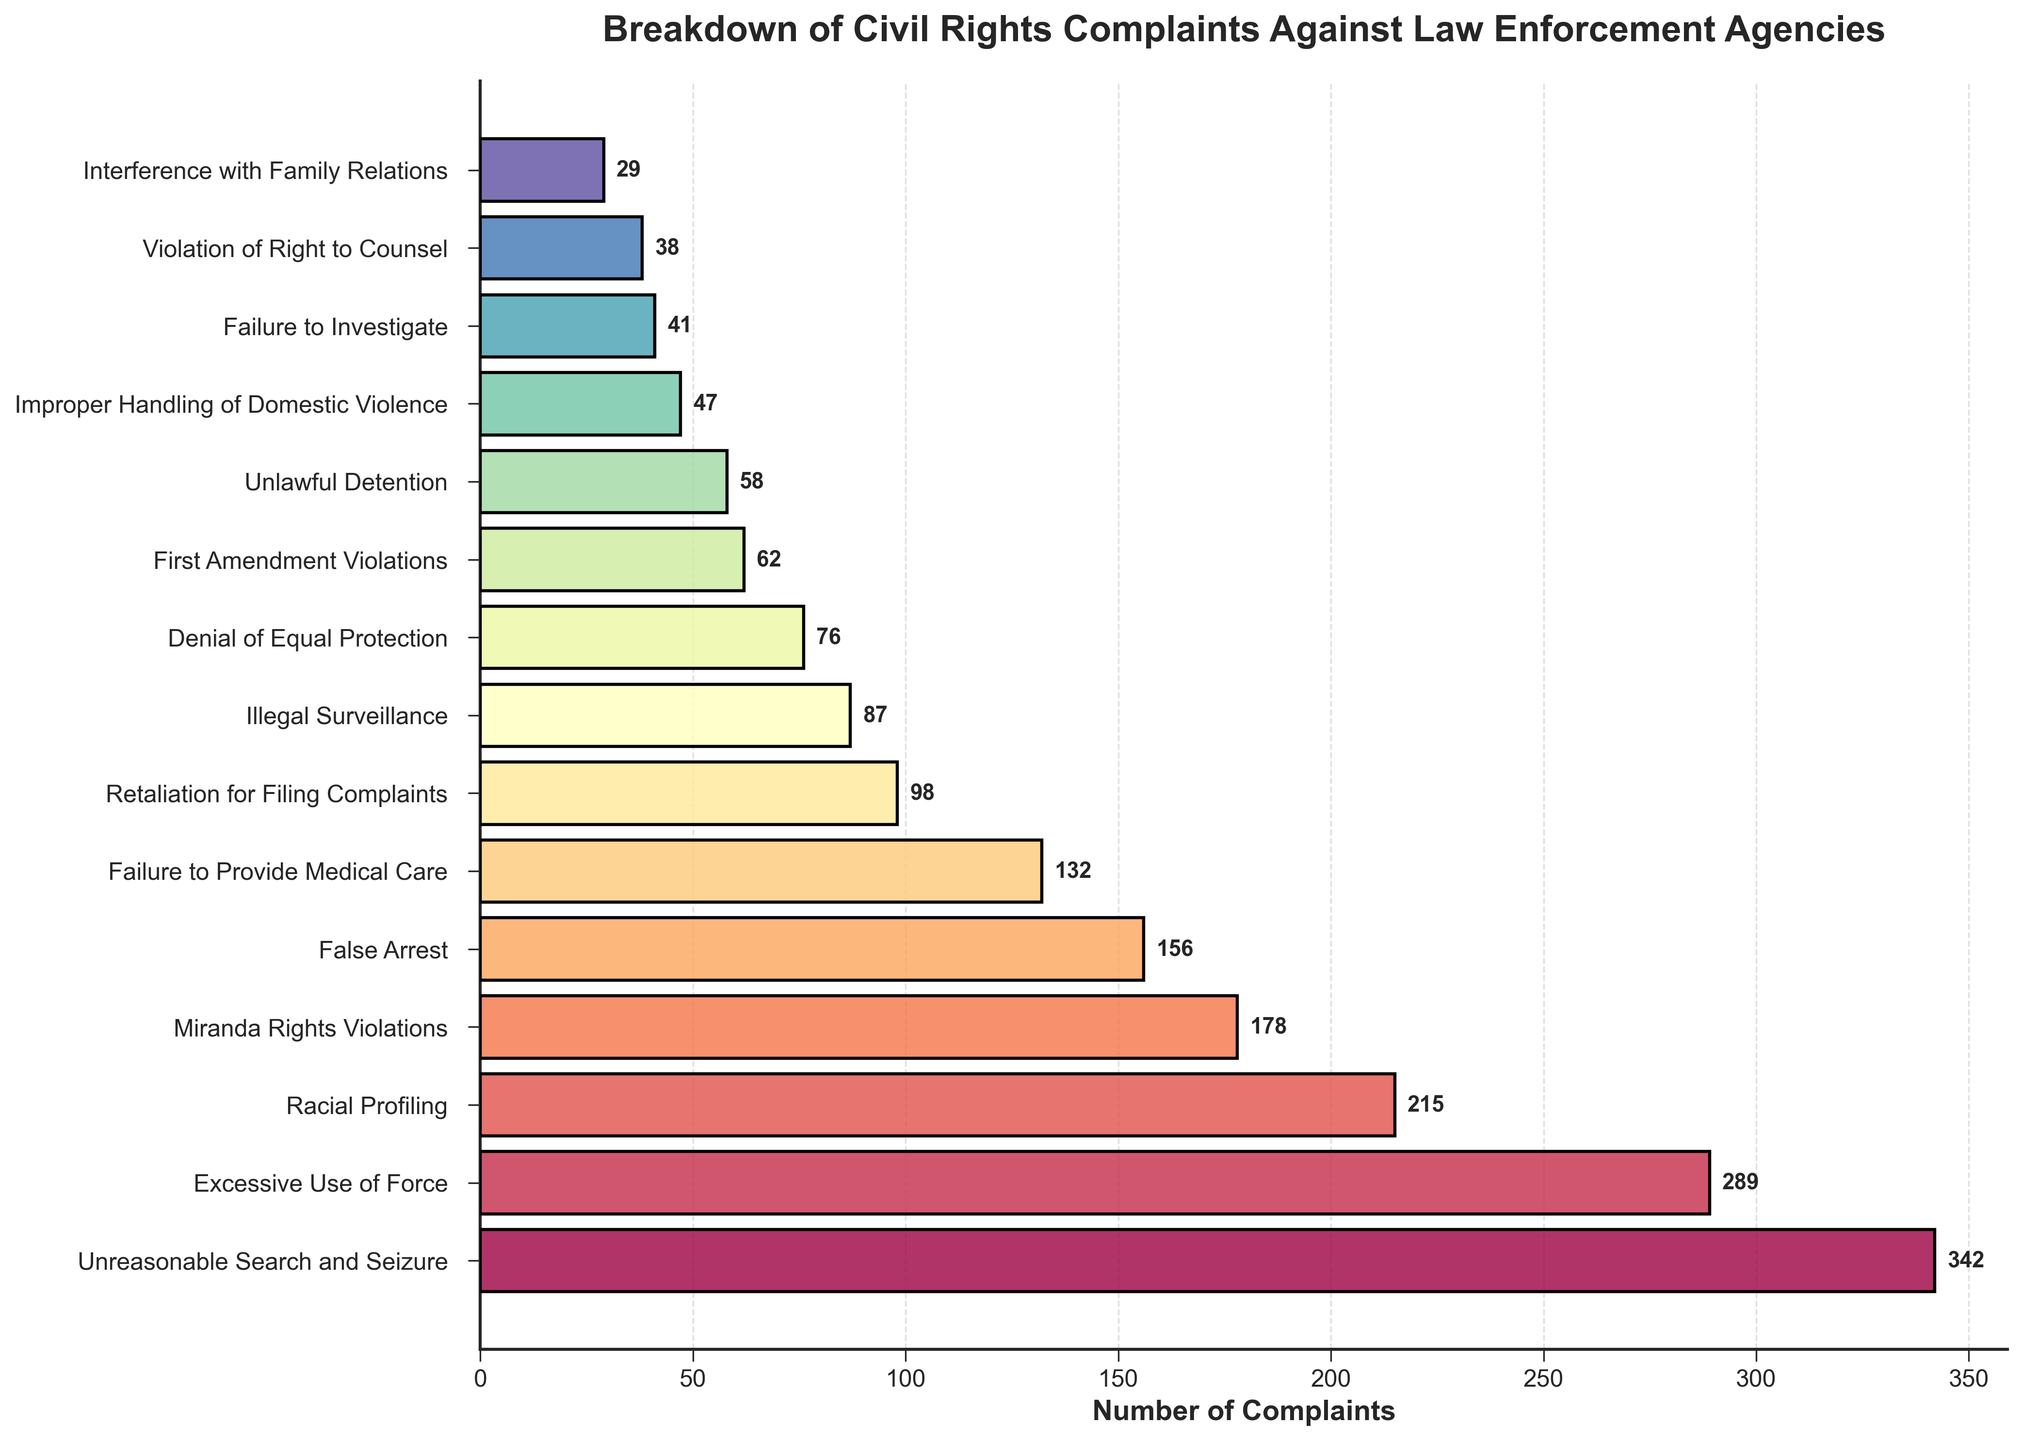What is the most common type of civil rights violation complaint? The most common type of civil rights violation complaint can be identified by finding the bar with the greatest length on the horizontal axis. The 'Unreasonable Search and Seizure' bar is the longest, indicating it has the highest number of complaints.
Answer: Unreasonable Search and Seizure Which civil rights violation has the least number of complaints? The least prevalent civil rights violation can be identified by finding the shortest bar on the horizontal axis. The 'Interference with Family Relations' bar is the shortest, showing it has the fewest complaints.
Answer: Interference with Family Relations How many more complaints are there for 'Excessive Use of Force' compared to 'Unlawful Detention'? Subtract the number of complaints for 'Unlawful Detention' from those for 'Excessive Use of Force'. The complaints for 'Excessive Use of Force' are 289, and for 'Unlawful Detention' are 58. Thus, 289 - 58 = 231.
Answer: 231 Are there more complaints related to 'Miranda Rights Violations' or 'Racial Profiling'? Compare the lengths of the bars for 'Miranda Rights Violations' and 'Racial Profiling'. The bar for 'Racial Profiling' (215 complaints) is longer than the bar for 'Miranda Rights Violations' (178 complaints).
Answer: Racial Profiling What is the combined total of complaints for 'False Arrest' and 'Denial of Equal Protection'? Add the number of complaints for 'False Arrest' and 'Denial of Equal Protection'. The complaints for 'False Arrest' are 156, and for 'Denial of Equal Protection' are 76. Thus, 156 + 76 = 232.
Answer: 232 Which violation type has the highest number of complaints and how many are there? Identify the violation type with the longest bar, which represents the highest number of complaints. 'Unreasonable Search and Seizure' has the longest bar with 342 complaints.
Answer: Unreasonable Search and Seizure, 342 Compare the number of complaints for 'Illegal Surveillance' and 'Failure to Provide Medical Care'. Which is higher, and by how many? Compare the lengths of the bars for 'Illegal Surveillance' (87 complaints) and 'Failure to Provide Medical Care' (132 complaints). 'Failure to Provide Medical Care' is higher by 132 - 87 = 45 complaints.
Answer: Failure to Provide Medical Care, 45 What proportion of the total complaints do 'Excessive Use of Force' and 'Racial Profiling' together account for? First, sum the complaints for 'Excessive Use of Force' (289) and 'Racial Profiling' (215) to get 504. Then, sum all the listed complaints: 342 + 289 + 215 + 178 + 156 + 132 + 98 + 87 + 76 + 62 + 58 + 47 + 41 + 38 + 29 = 1740. Finally, divide 504 by 1740 and multiply by 100 to convert to a percentage: (504/1740) * 100 ≈ 28.97%.
Answer: Approximately 28.97% How many more complaints are there for 'False Arrest' compared to 'Impropser Handling of Domestic Violence'? Subtract the number of complaints for 'Improper Handling of Domestic Violence' from those for 'False Arrest'. The complaints for 'False Arrest' are 156, and for 'Improper Handling of Domestic Violence' are 47. Thus, 156 - 47 = 109.
Answer: 109 